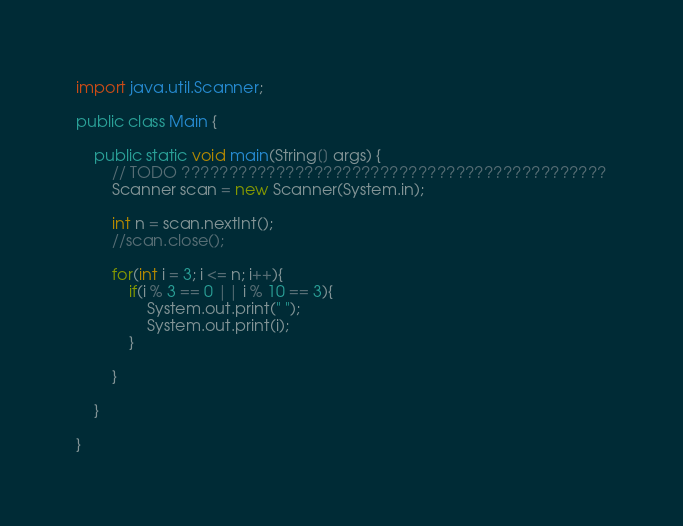Convert code to text. <code><loc_0><loc_0><loc_500><loc_500><_Java_>import java.util.Scanner;
 
public class Main {
 
    public static void main(String[] args) {
        // TODO ?????????????????????????????????????????????
        Scanner scan = new Scanner(System.in);
         
        int n = scan.nextInt();
        //scan.close();
         
        for(int i = 3; i <= n; i++){
            if(i % 3 == 0 || i % 10 == 3){
                System.out.print(" ");
                System.out.print(i);
            }
             
        }
         
    }
 
}</code> 